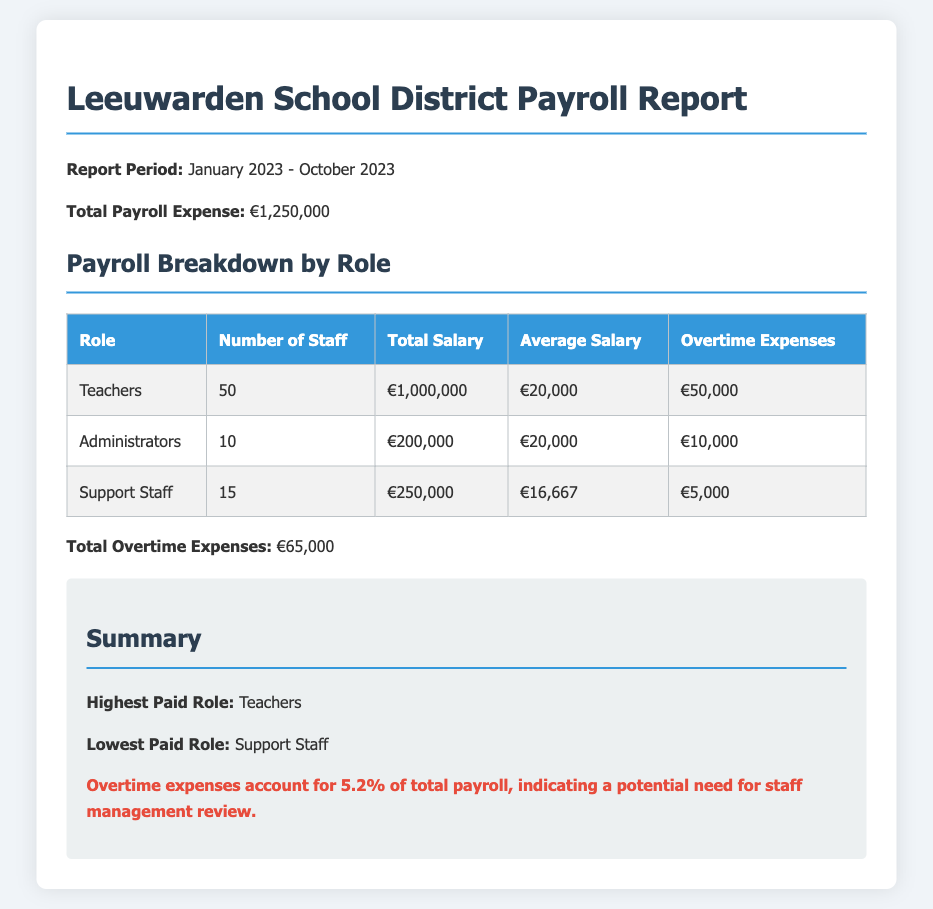What is the report period? The report period is specified in the document, indicating the timeframe covered by the payroll report.
Answer: January 2023 - October 2023 What is the total payroll expense? The total payroll expense is explicitly stated in the document as part of the summary.
Answer: €1,250,000 How many teachers are there? The number of teachers is provided in the payroll breakdown table under the staff numbers.
Answer: 50 What is the total overtime expenses? The total overtime expenses are highlighted in the document as a separate figure under the payroll breakdown.
Answer: €65,000 What is the average salary of support staff? The average salary for support staff is provided in the table, which breaks down salaries by role.
Answer: €16,667 Which role has the highest total salary? The role with the highest total salary is identified in the summary section of the report.
Answer: Teachers What percentage of the total payroll do overtime expenses account for? The document states that overtime expenses are a certain percentage of the total payroll, which is calculated in the summary.
Answer: 5.2% How many administrators are there? The number of administrators is listed in the payroll breakdown table.
Answer: 10 What is the lowest paid role? The lowest paid role is mentioned in the summary of the report.
Answer: Support Staff 